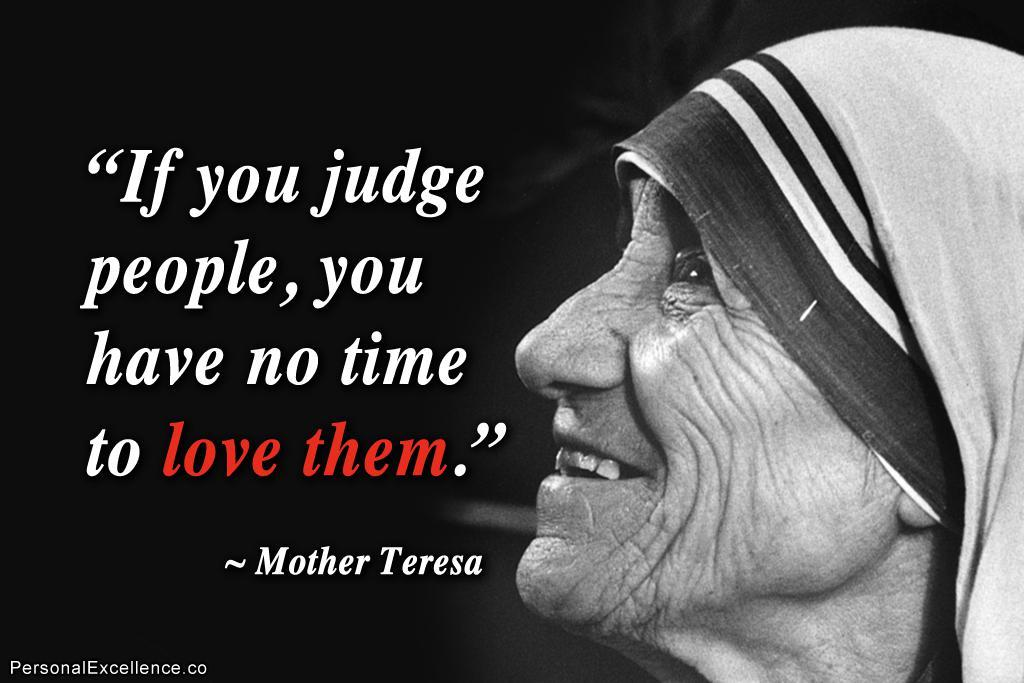What is the main object in the image? There is a poster in the image. What is depicted on the poster? The poster contains a picture of a woman. What else can be found on the poster besides the image? There is text written on the poster. How does the faucet contribute to the message of the poster? There is no faucet present in the image, so it cannot contribute to the message of the poster. 